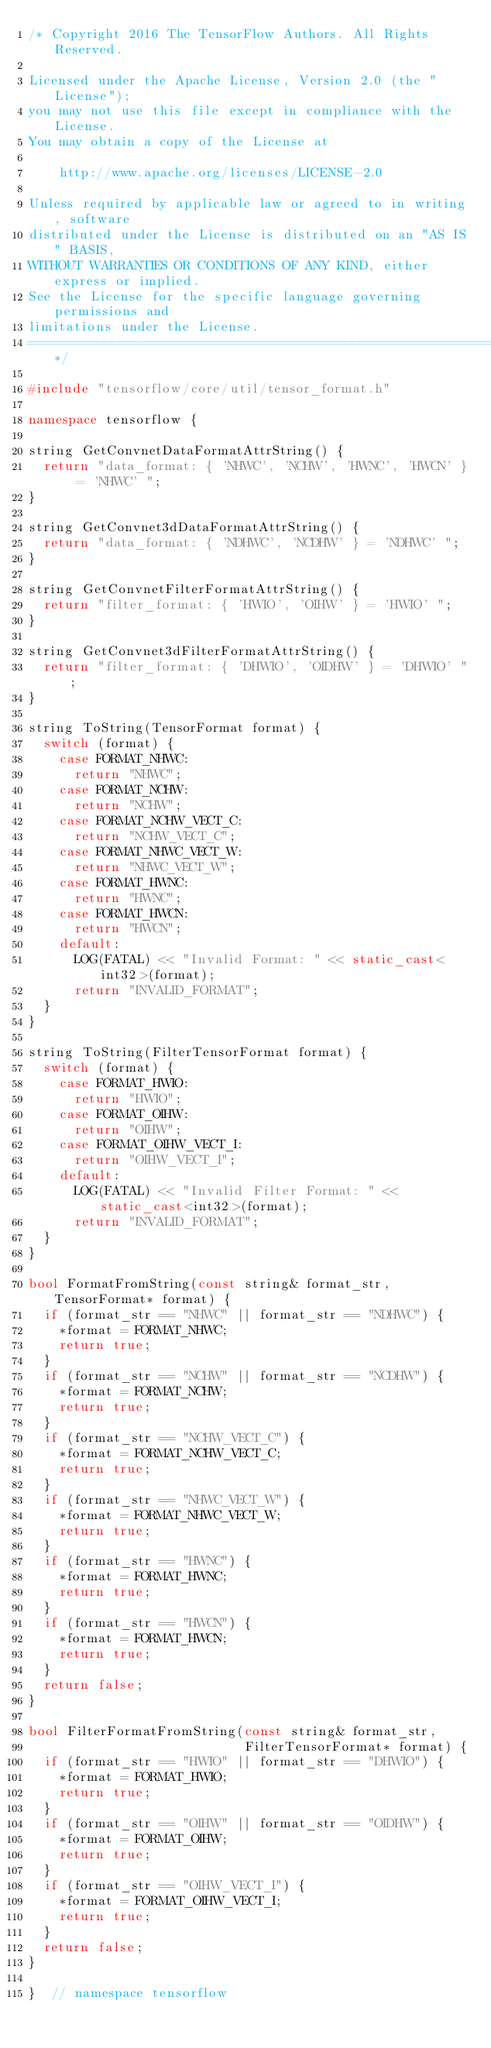<code> <loc_0><loc_0><loc_500><loc_500><_C++_>/* Copyright 2016 The TensorFlow Authors. All Rights Reserved.

Licensed under the Apache License, Version 2.0 (the "License");
you may not use this file except in compliance with the License.
You may obtain a copy of the License at

    http://www.apache.org/licenses/LICENSE-2.0

Unless required by applicable law or agreed to in writing, software
distributed under the License is distributed on an "AS IS" BASIS,
WITHOUT WARRANTIES OR CONDITIONS OF ANY KIND, either express or implied.
See the License for the specific language governing permissions and
limitations under the License.
==============================================================================*/

#include "tensorflow/core/util/tensor_format.h"

namespace tensorflow {

string GetConvnetDataFormatAttrString() {
  return "data_format: { 'NHWC', 'NCHW', 'HWNC', 'HWCN' } = 'NHWC' ";
}

string GetConvnet3dDataFormatAttrString() {
  return "data_format: { 'NDHWC', 'NCDHW' } = 'NDHWC' ";
}

string GetConvnetFilterFormatAttrString() {
  return "filter_format: { 'HWIO', 'OIHW' } = 'HWIO' ";
}

string GetConvnet3dFilterFormatAttrString() {
  return "filter_format: { 'DHWIO', 'OIDHW' } = 'DHWIO' ";
}

string ToString(TensorFormat format) {
  switch (format) {
    case FORMAT_NHWC:
      return "NHWC";
    case FORMAT_NCHW:
      return "NCHW";
    case FORMAT_NCHW_VECT_C:
      return "NCHW_VECT_C";
    case FORMAT_NHWC_VECT_W:
      return "NHWC_VECT_W";
    case FORMAT_HWNC:
      return "HWNC";
    case FORMAT_HWCN:
      return "HWCN";
    default:
      LOG(FATAL) << "Invalid Format: " << static_cast<int32>(format);
      return "INVALID_FORMAT";
  }
}

string ToString(FilterTensorFormat format) {
  switch (format) {
    case FORMAT_HWIO:
      return "HWIO";
    case FORMAT_OIHW:
      return "OIHW";
    case FORMAT_OIHW_VECT_I:
      return "OIHW_VECT_I";
    default:
      LOG(FATAL) << "Invalid Filter Format: " << static_cast<int32>(format);
      return "INVALID_FORMAT";
  }
}

bool FormatFromString(const string& format_str, TensorFormat* format) {
  if (format_str == "NHWC" || format_str == "NDHWC") {
    *format = FORMAT_NHWC;
    return true;
  }
  if (format_str == "NCHW" || format_str == "NCDHW") {
    *format = FORMAT_NCHW;
    return true;
  }
  if (format_str == "NCHW_VECT_C") {
    *format = FORMAT_NCHW_VECT_C;
    return true;
  }
  if (format_str == "NHWC_VECT_W") {
    *format = FORMAT_NHWC_VECT_W;
    return true;
  }
  if (format_str == "HWNC") {
    *format = FORMAT_HWNC;
    return true;
  }
  if (format_str == "HWCN") {
    *format = FORMAT_HWCN;
    return true;
  }
  return false;
}

bool FilterFormatFromString(const string& format_str,
                            FilterTensorFormat* format) {
  if (format_str == "HWIO" || format_str == "DHWIO") {
    *format = FORMAT_HWIO;
    return true;
  }
  if (format_str == "OIHW" || format_str == "OIDHW") {
    *format = FORMAT_OIHW;
    return true;
  }
  if (format_str == "OIHW_VECT_I") {
    *format = FORMAT_OIHW_VECT_I;
    return true;
  }
  return false;
}

}  // namespace tensorflow
</code> 